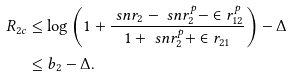Convert formula to latex. <formula><loc_0><loc_0><loc_500><loc_500>R _ { 2 c } & \leq \log \left ( 1 + \frac { \ s n r _ { 2 } - \ s n r _ { 2 } ^ { p } - \in r _ { 1 2 } ^ { p } } { 1 + \ s n r _ { 2 } ^ { p } + \in r _ { 2 1 } } \right ) - \Delta \\ & \leq b _ { 2 } - \Delta .</formula> 